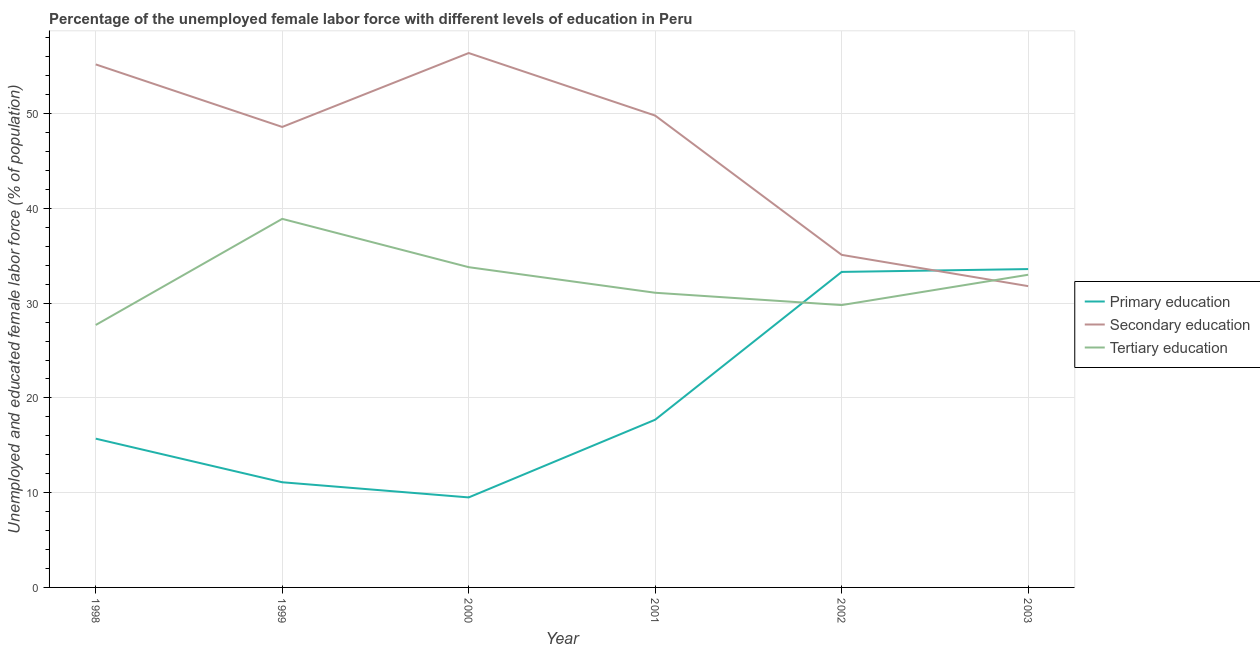Is the number of lines equal to the number of legend labels?
Make the answer very short. Yes. What is the percentage of female labor force who received primary education in 1999?
Offer a very short reply. 11.1. Across all years, what is the maximum percentage of female labor force who received primary education?
Offer a terse response. 33.6. Across all years, what is the minimum percentage of female labor force who received primary education?
Offer a very short reply. 9.5. What is the total percentage of female labor force who received tertiary education in the graph?
Your response must be concise. 194.3. What is the difference between the percentage of female labor force who received tertiary education in 1998 and that in 2000?
Your answer should be compact. -6.1. What is the difference between the percentage of female labor force who received tertiary education in 2001 and the percentage of female labor force who received secondary education in 2000?
Keep it short and to the point. -25.3. What is the average percentage of female labor force who received primary education per year?
Provide a succinct answer. 20.15. In the year 2003, what is the difference between the percentage of female labor force who received primary education and percentage of female labor force who received tertiary education?
Ensure brevity in your answer.  0.6. What is the ratio of the percentage of female labor force who received tertiary education in 1998 to that in 2001?
Offer a very short reply. 0.89. Is the percentage of female labor force who received primary education in 1998 less than that in 2001?
Provide a succinct answer. Yes. What is the difference between the highest and the second highest percentage of female labor force who received secondary education?
Provide a short and direct response. 1.2. What is the difference between the highest and the lowest percentage of female labor force who received primary education?
Keep it short and to the point. 24.1. In how many years, is the percentage of female labor force who received tertiary education greater than the average percentage of female labor force who received tertiary education taken over all years?
Your response must be concise. 3. Is the sum of the percentage of female labor force who received tertiary education in 1998 and 1999 greater than the maximum percentage of female labor force who received primary education across all years?
Ensure brevity in your answer.  Yes. Is it the case that in every year, the sum of the percentage of female labor force who received primary education and percentage of female labor force who received secondary education is greater than the percentage of female labor force who received tertiary education?
Give a very brief answer. Yes. Does the percentage of female labor force who received secondary education monotonically increase over the years?
Keep it short and to the point. No. Is the percentage of female labor force who received secondary education strictly less than the percentage of female labor force who received primary education over the years?
Offer a very short reply. No. How many lines are there?
Your response must be concise. 3. How many years are there in the graph?
Make the answer very short. 6. What is the difference between two consecutive major ticks on the Y-axis?
Keep it short and to the point. 10. Does the graph contain any zero values?
Give a very brief answer. No. Does the graph contain grids?
Give a very brief answer. Yes. How many legend labels are there?
Your answer should be compact. 3. How are the legend labels stacked?
Offer a terse response. Vertical. What is the title of the graph?
Provide a short and direct response. Percentage of the unemployed female labor force with different levels of education in Peru. What is the label or title of the X-axis?
Keep it short and to the point. Year. What is the label or title of the Y-axis?
Keep it short and to the point. Unemployed and educated female labor force (% of population). What is the Unemployed and educated female labor force (% of population) in Primary education in 1998?
Offer a very short reply. 15.7. What is the Unemployed and educated female labor force (% of population) of Secondary education in 1998?
Offer a terse response. 55.2. What is the Unemployed and educated female labor force (% of population) in Tertiary education in 1998?
Offer a very short reply. 27.7. What is the Unemployed and educated female labor force (% of population) of Primary education in 1999?
Offer a terse response. 11.1. What is the Unemployed and educated female labor force (% of population) in Secondary education in 1999?
Your answer should be very brief. 48.6. What is the Unemployed and educated female labor force (% of population) in Tertiary education in 1999?
Offer a very short reply. 38.9. What is the Unemployed and educated female labor force (% of population) of Secondary education in 2000?
Your answer should be very brief. 56.4. What is the Unemployed and educated female labor force (% of population) in Tertiary education in 2000?
Provide a succinct answer. 33.8. What is the Unemployed and educated female labor force (% of population) in Primary education in 2001?
Ensure brevity in your answer.  17.7. What is the Unemployed and educated female labor force (% of population) in Secondary education in 2001?
Your answer should be very brief. 49.8. What is the Unemployed and educated female labor force (% of population) of Tertiary education in 2001?
Your answer should be compact. 31.1. What is the Unemployed and educated female labor force (% of population) in Primary education in 2002?
Your answer should be very brief. 33.3. What is the Unemployed and educated female labor force (% of population) in Secondary education in 2002?
Your answer should be very brief. 35.1. What is the Unemployed and educated female labor force (% of population) in Tertiary education in 2002?
Provide a short and direct response. 29.8. What is the Unemployed and educated female labor force (% of population) in Primary education in 2003?
Ensure brevity in your answer.  33.6. What is the Unemployed and educated female labor force (% of population) of Secondary education in 2003?
Your response must be concise. 31.8. Across all years, what is the maximum Unemployed and educated female labor force (% of population) of Primary education?
Give a very brief answer. 33.6. Across all years, what is the maximum Unemployed and educated female labor force (% of population) of Secondary education?
Your answer should be very brief. 56.4. Across all years, what is the maximum Unemployed and educated female labor force (% of population) in Tertiary education?
Your response must be concise. 38.9. Across all years, what is the minimum Unemployed and educated female labor force (% of population) of Primary education?
Ensure brevity in your answer.  9.5. Across all years, what is the minimum Unemployed and educated female labor force (% of population) of Secondary education?
Give a very brief answer. 31.8. Across all years, what is the minimum Unemployed and educated female labor force (% of population) in Tertiary education?
Keep it short and to the point. 27.7. What is the total Unemployed and educated female labor force (% of population) in Primary education in the graph?
Give a very brief answer. 120.9. What is the total Unemployed and educated female labor force (% of population) in Secondary education in the graph?
Provide a succinct answer. 276.9. What is the total Unemployed and educated female labor force (% of population) in Tertiary education in the graph?
Your answer should be compact. 194.3. What is the difference between the Unemployed and educated female labor force (% of population) in Primary education in 1998 and that in 1999?
Give a very brief answer. 4.6. What is the difference between the Unemployed and educated female labor force (% of population) in Tertiary education in 1998 and that in 1999?
Ensure brevity in your answer.  -11.2. What is the difference between the Unemployed and educated female labor force (% of population) of Secondary education in 1998 and that in 2001?
Your response must be concise. 5.4. What is the difference between the Unemployed and educated female labor force (% of population) of Tertiary education in 1998 and that in 2001?
Your answer should be very brief. -3.4. What is the difference between the Unemployed and educated female labor force (% of population) in Primary education in 1998 and that in 2002?
Ensure brevity in your answer.  -17.6. What is the difference between the Unemployed and educated female labor force (% of population) of Secondary education in 1998 and that in 2002?
Provide a short and direct response. 20.1. What is the difference between the Unemployed and educated female labor force (% of population) of Tertiary education in 1998 and that in 2002?
Your answer should be very brief. -2.1. What is the difference between the Unemployed and educated female labor force (% of population) of Primary education in 1998 and that in 2003?
Your answer should be very brief. -17.9. What is the difference between the Unemployed and educated female labor force (% of population) of Secondary education in 1998 and that in 2003?
Your answer should be compact. 23.4. What is the difference between the Unemployed and educated female labor force (% of population) of Secondary education in 1999 and that in 2000?
Ensure brevity in your answer.  -7.8. What is the difference between the Unemployed and educated female labor force (% of population) of Primary education in 1999 and that in 2001?
Ensure brevity in your answer.  -6.6. What is the difference between the Unemployed and educated female labor force (% of population) in Secondary education in 1999 and that in 2001?
Your response must be concise. -1.2. What is the difference between the Unemployed and educated female labor force (% of population) in Tertiary education in 1999 and that in 2001?
Your answer should be very brief. 7.8. What is the difference between the Unemployed and educated female labor force (% of population) of Primary education in 1999 and that in 2002?
Offer a very short reply. -22.2. What is the difference between the Unemployed and educated female labor force (% of population) in Secondary education in 1999 and that in 2002?
Offer a terse response. 13.5. What is the difference between the Unemployed and educated female labor force (% of population) of Primary education in 1999 and that in 2003?
Offer a very short reply. -22.5. What is the difference between the Unemployed and educated female labor force (% of population) of Primary education in 2000 and that in 2001?
Make the answer very short. -8.2. What is the difference between the Unemployed and educated female labor force (% of population) of Secondary education in 2000 and that in 2001?
Offer a terse response. 6.6. What is the difference between the Unemployed and educated female labor force (% of population) in Tertiary education in 2000 and that in 2001?
Give a very brief answer. 2.7. What is the difference between the Unemployed and educated female labor force (% of population) of Primary education in 2000 and that in 2002?
Your answer should be compact. -23.8. What is the difference between the Unemployed and educated female labor force (% of population) of Secondary education in 2000 and that in 2002?
Offer a very short reply. 21.3. What is the difference between the Unemployed and educated female labor force (% of population) of Tertiary education in 2000 and that in 2002?
Provide a short and direct response. 4. What is the difference between the Unemployed and educated female labor force (% of population) in Primary education in 2000 and that in 2003?
Provide a short and direct response. -24.1. What is the difference between the Unemployed and educated female labor force (% of population) in Secondary education in 2000 and that in 2003?
Your answer should be very brief. 24.6. What is the difference between the Unemployed and educated female labor force (% of population) of Tertiary education in 2000 and that in 2003?
Provide a short and direct response. 0.8. What is the difference between the Unemployed and educated female labor force (% of population) of Primary education in 2001 and that in 2002?
Make the answer very short. -15.6. What is the difference between the Unemployed and educated female labor force (% of population) of Tertiary education in 2001 and that in 2002?
Provide a short and direct response. 1.3. What is the difference between the Unemployed and educated female labor force (% of population) in Primary education in 2001 and that in 2003?
Your response must be concise. -15.9. What is the difference between the Unemployed and educated female labor force (% of population) of Tertiary education in 2001 and that in 2003?
Your response must be concise. -1.9. What is the difference between the Unemployed and educated female labor force (% of population) in Secondary education in 2002 and that in 2003?
Your answer should be compact. 3.3. What is the difference between the Unemployed and educated female labor force (% of population) in Primary education in 1998 and the Unemployed and educated female labor force (% of population) in Secondary education in 1999?
Make the answer very short. -32.9. What is the difference between the Unemployed and educated female labor force (% of population) of Primary education in 1998 and the Unemployed and educated female labor force (% of population) of Tertiary education in 1999?
Offer a very short reply. -23.2. What is the difference between the Unemployed and educated female labor force (% of population) in Secondary education in 1998 and the Unemployed and educated female labor force (% of population) in Tertiary education in 1999?
Give a very brief answer. 16.3. What is the difference between the Unemployed and educated female labor force (% of population) in Primary education in 1998 and the Unemployed and educated female labor force (% of population) in Secondary education in 2000?
Make the answer very short. -40.7. What is the difference between the Unemployed and educated female labor force (% of population) of Primary education in 1998 and the Unemployed and educated female labor force (% of population) of Tertiary education in 2000?
Provide a short and direct response. -18.1. What is the difference between the Unemployed and educated female labor force (% of population) in Secondary education in 1998 and the Unemployed and educated female labor force (% of population) in Tertiary education in 2000?
Give a very brief answer. 21.4. What is the difference between the Unemployed and educated female labor force (% of population) of Primary education in 1998 and the Unemployed and educated female labor force (% of population) of Secondary education in 2001?
Offer a terse response. -34.1. What is the difference between the Unemployed and educated female labor force (% of population) in Primary education in 1998 and the Unemployed and educated female labor force (% of population) in Tertiary education in 2001?
Your answer should be very brief. -15.4. What is the difference between the Unemployed and educated female labor force (% of population) in Secondary education in 1998 and the Unemployed and educated female labor force (% of population) in Tertiary education in 2001?
Offer a terse response. 24.1. What is the difference between the Unemployed and educated female labor force (% of population) of Primary education in 1998 and the Unemployed and educated female labor force (% of population) of Secondary education in 2002?
Keep it short and to the point. -19.4. What is the difference between the Unemployed and educated female labor force (% of population) of Primary education in 1998 and the Unemployed and educated female labor force (% of population) of Tertiary education in 2002?
Provide a short and direct response. -14.1. What is the difference between the Unemployed and educated female labor force (% of population) in Secondary education in 1998 and the Unemployed and educated female labor force (% of population) in Tertiary education in 2002?
Your answer should be very brief. 25.4. What is the difference between the Unemployed and educated female labor force (% of population) of Primary education in 1998 and the Unemployed and educated female labor force (% of population) of Secondary education in 2003?
Provide a short and direct response. -16.1. What is the difference between the Unemployed and educated female labor force (% of population) in Primary education in 1998 and the Unemployed and educated female labor force (% of population) in Tertiary education in 2003?
Offer a very short reply. -17.3. What is the difference between the Unemployed and educated female labor force (% of population) in Primary education in 1999 and the Unemployed and educated female labor force (% of population) in Secondary education in 2000?
Offer a terse response. -45.3. What is the difference between the Unemployed and educated female labor force (% of population) of Primary education in 1999 and the Unemployed and educated female labor force (% of population) of Tertiary education in 2000?
Make the answer very short. -22.7. What is the difference between the Unemployed and educated female labor force (% of population) in Secondary education in 1999 and the Unemployed and educated female labor force (% of population) in Tertiary education in 2000?
Ensure brevity in your answer.  14.8. What is the difference between the Unemployed and educated female labor force (% of population) in Primary education in 1999 and the Unemployed and educated female labor force (% of population) in Secondary education in 2001?
Offer a very short reply. -38.7. What is the difference between the Unemployed and educated female labor force (% of population) in Primary education in 1999 and the Unemployed and educated female labor force (% of population) in Tertiary education in 2001?
Offer a very short reply. -20. What is the difference between the Unemployed and educated female labor force (% of population) of Secondary education in 1999 and the Unemployed and educated female labor force (% of population) of Tertiary education in 2001?
Offer a terse response. 17.5. What is the difference between the Unemployed and educated female labor force (% of population) in Primary education in 1999 and the Unemployed and educated female labor force (% of population) in Secondary education in 2002?
Offer a terse response. -24. What is the difference between the Unemployed and educated female labor force (% of population) in Primary education in 1999 and the Unemployed and educated female labor force (% of population) in Tertiary education in 2002?
Make the answer very short. -18.7. What is the difference between the Unemployed and educated female labor force (% of population) in Secondary education in 1999 and the Unemployed and educated female labor force (% of population) in Tertiary education in 2002?
Ensure brevity in your answer.  18.8. What is the difference between the Unemployed and educated female labor force (% of population) of Primary education in 1999 and the Unemployed and educated female labor force (% of population) of Secondary education in 2003?
Offer a terse response. -20.7. What is the difference between the Unemployed and educated female labor force (% of population) in Primary education in 1999 and the Unemployed and educated female labor force (% of population) in Tertiary education in 2003?
Ensure brevity in your answer.  -21.9. What is the difference between the Unemployed and educated female labor force (% of population) in Primary education in 2000 and the Unemployed and educated female labor force (% of population) in Secondary education in 2001?
Your answer should be very brief. -40.3. What is the difference between the Unemployed and educated female labor force (% of population) of Primary education in 2000 and the Unemployed and educated female labor force (% of population) of Tertiary education in 2001?
Give a very brief answer. -21.6. What is the difference between the Unemployed and educated female labor force (% of population) in Secondary education in 2000 and the Unemployed and educated female labor force (% of population) in Tertiary education in 2001?
Your answer should be very brief. 25.3. What is the difference between the Unemployed and educated female labor force (% of population) in Primary education in 2000 and the Unemployed and educated female labor force (% of population) in Secondary education in 2002?
Offer a terse response. -25.6. What is the difference between the Unemployed and educated female labor force (% of population) of Primary education in 2000 and the Unemployed and educated female labor force (% of population) of Tertiary education in 2002?
Your response must be concise. -20.3. What is the difference between the Unemployed and educated female labor force (% of population) in Secondary education in 2000 and the Unemployed and educated female labor force (% of population) in Tertiary education in 2002?
Offer a terse response. 26.6. What is the difference between the Unemployed and educated female labor force (% of population) in Primary education in 2000 and the Unemployed and educated female labor force (% of population) in Secondary education in 2003?
Your answer should be very brief. -22.3. What is the difference between the Unemployed and educated female labor force (% of population) in Primary education in 2000 and the Unemployed and educated female labor force (% of population) in Tertiary education in 2003?
Keep it short and to the point. -23.5. What is the difference between the Unemployed and educated female labor force (% of population) of Secondary education in 2000 and the Unemployed and educated female labor force (% of population) of Tertiary education in 2003?
Provide a short and direct response. 23.4. What is the difference between the Unemployed and educated female labor force (% of population) of Primary education in 2001 and the Unemployed and educated female labor force (% of population) of Secondary education in 2002?
Provide a succinct answer. -17.4. What is the difference between the Unemployed and educated female labor force (% of population) of Primary education in 2001 and the Unemployed and educated female labor force (% of population) of Tertiary education in 2002?
Make the answer very short. -12.1. What is the difference between the Unemployed and educated female labor force (% of population) in Primary education in 2001 and the Unemployed and educated female labor force (% of population) in Secondary education in 2003?
Your response must be concise. -14.1. What is the difference between the Unemployed and educated female labor force (% of population) of Primary education in 2001 and the Unemployed and educated female labor force (% of population) of Tertiary education in 2003?
Give a very brief answer. -15.3. What is the difference between the Unemployed and educated female labor force (% of population) in Secondary education in 2001 and the Unemployed and educated female labor force (% of population) in Tertiary education in 2003?
Your answer should be very brief. 16.8. What is the difference between the Unemployed and educated female labor force (% of population) of Primary education in 2002 and the Unemployed and educated female labor force (% of population) of Secondary education in 2003?
Make the answer very short. 1.5. What is the average Unemployed and educated female labor force (% of population) in Primary education per year?
Provide a short and direct response. 20.15. What is the average Unemployed and educated female labor force (% of population) of Secondary education per year?
Your answer should be compact. 46.15. What is the average Unemployed and educated female labor force (% of population) of Tertiary education per year?
Give a very brief answer. 32.38. In the year 1998, what is the difference between the Unemployed and educated female labor force (% of population) in Primary education and Unemployed and educated female labor force (% of population) in Secondary education?
Your response must be concise. -39.5. In the year 1998, what is the difference between the Unemployed and educated female labor force (% of population) in Primary education and Unemployed and educated female labor force (% of population) in Tertiary education?
Offer a very short reply. -12. In the year 1999, what is the difference between the Unemployed and educated female labor force (% of population) of Primary education and Unemployed and educated female labor force (% of population) of Secondary education?
Offer a very short reply. -37.5. In the year 1999, what is the difference between the Unemployed and educated female labor force (% of population) of Primary education and Unemployed and educated female labor force (% of population) of Tertiary education?
Give a very brief answer. -27.8. In the year 1999, what is the difference between the Unemployed and educated female labor force (% of population) of Secondary education and Unemployed and educated female labor force (% of population) of Tertiary education?
Your answer should be very brief. 9.7. In the year 2000, what is the difference between the Unemployed and educated female labor force (% of population) of Primary education and Unemployed and educated female labor force (% of population) of Secondary education?
Provide a short and direct response. -46.9. In the year 2000, what is the difference between the Unemployed and educated female labor force (% of population) in Primary education and Unemployed and educated female labor force (% of population) in Tertiary education?
Ensure brevity in your answer.  -24.3. In the year 2000, what is the difference between the Unemployed and educated female labor force (% of population) in Secondary education and Unemployed and educated female labor force (% of population) in Tertiary education?
Your response must be concise. 22.6. In the year 2001, what is the difference between the Unemployed and educated female labor force (% of population) in Primary education and Unemployed and educated female labor force (% of population) in Secondary education?
Your answer should be compact. -32.1. In the year 2001, what is the difference between the Unemployed and educated female labor force (% of population) in Primary education and Unemployed and educated female labor force (% of population) in Tertiary education?
Your answer should be very brief. -13.4. In the year 2001, what is the difference between the Unemployed and educated female labor force (% of population) in Secondary education and Unemployed and educated female labor force (% of population) in Tertiary education?
Make the answer very short. 18.7. In the year 2002, what is the difference between the Unemployed and educated female labor force (% of population) in Primary education and Unemployed and educated female labor force (% of population) in Tertiary education?
Offer a terse response. 3.5. In the year 2003, what is the difference between the Unemployed and educated female labor force (% of population) in Primary education and Unemployed and educated female labor force (% of population) in Secondary education?
Provide a succinct answer. 1.8. What is the ratio of the Unemployed and educated female labor force (% of population) in Primary education in 1998 to that in 1999?
Offer a very short reply. 1.41. What is the ratio of the Unemployed and educated female labor force (% of population) in Secondary education in 1998 to that in 1999?
Ensure brevity in your answer.  1.14. What is the ratio of the Unemployed and educated female labor force (% of population) of Tertiary education in 1998 to that in 1999?
Offer a very short reply. 0.71. What is the ratio of the Unemployed and educated female labor force (% of population) in Primary education in 1998 to that in 2000?
Provide a succinct answer. 1.65. What is the ratio of the Unemployed and educated female labor force (% of population) in Secondary education in 1998 to that in 2000?
Your answer should be compact. 0.98. What is the ratio of the Unemployed and educated female labor force (% of population) in Tertiary education in 1998 to that in 2000?
Ensure brevity in your answer.  0.82. What is the ratio of the Unemployed and educated female labor force (% of population) in Primary education in 1998 to that in 2001?
Keep it short and to the point. 0.89. What is the ratio of the Unemployed and educated female labor force (% of population) in Secondary education in 1998 to that in 2001?
Ensure brevity in your answer.  1.11. What is the ratio of the Unemployed and educated female labor force (% of population) in Tertiary education in 1998 to that in 2001?
Make the answer very short. 0.89. What is the ratio of the Unemployed and educated female labor force (% of population) of Primary education in 1998 to that in 2002?
Offer a terse response. 0.47. What is the ratio of the Unemployed and educated female labor force (% of population) in Secondary education in 1998 to that in 2002?
Provide a succinct answer. 1.57. What is the ratio of the Unemployed and educated female labor force (% of population) in Tertiary education in 1998 to that in 2002?
Make the answer very short. 0.93. What is the ratio of the Unemployed and educated female labor force (% of population) in Primary education in 1998 to that in 2003?
Ensure brevity in your answer.  0.47. What is the ratio of the Unemployed and educated female labor force (% of population) of Secondary education in 1998 to that in 2003?
Offer a very short reply. 1.74. What is the ratio of the Unemployed and educated female labor force (% of population) of Tertiary education in 1998 to that in 2003?
Make the answer very short. 0.84. What is the ratio of the Unemployed and educated female labor force (% of population) of Primary education in 1999 to that in 2000?
Your response must be concise. 1.17. What is the ratio of the Unemployed and educated female labor force (% of population) in Secondary education in 1999 to that in 2000?
Provide a succinct answer. 0.86. What is the ratio of the Unemployed and educated female labor force (% of population) in Tertiary education in 1999 to that in 2000?
Ensure brevity in your answer.  1.15. What is the ratio of the Unemployed and educated female labor force (% of population) of Primary education in 1999 to that in 2001?
Make the answer very short. 0.63. What is the ratio of the Unemployed and educated female labor force (% of population) in Secondary education in 1999 to that in 2001?
Your answer should be compact. 0.98. What is the ratio of the Unemployed and educated female labor force (% of population) of Tertiary education in 1999 to that in 2001?
Your response must be concise. 1.25. What is the ratio of the Unemployed and educated female labor force (% of population) in Secondary education in 1999 to that in 2002?
Keep it short and to the point. 1.38. What is the ratio of the Unemployed and educated female labor force (% of population) in Tertiary education in 1999 to that in 2002?
Offer a very short reply. 1.31. What is the ratio of the Unemployed and educated female labor force (% of population) of Primary education in 1999 to that in 2003?
Keep it short and to the point. 0.33. What is the ratio of the Unemployed and educated female labor force (% of population) in Secondary education in 1999 to that in 2003?
Your answer should be compact. 1.53. What is the ratio of the Unemployed and educated female labor force (% of population) of Tertiary education in 1999 to that in 2003?
Your answer should be compact. 1.18. What is the ratio of the Unemployed and educated female labor force (% of population) of Primary education in 2000 to that in 2001?
Offer a very short reply. 0.54. What is the ratio of the Unemployed and educated female labor force (% of population) of Secondary education in 2000 to that in 2001?
Ensure brevity in your answer.  1.13. What is the ratio of the Unemployed and educated female labor force (% of population) in Tertiary education in 2000 to that in 2001?
Keep it short and to the point. 1.09. What is the ratio of the Unemployed and educated female labor force (% of population) of Primary education in 2000 to that in 2002?
Your response must be concise. 0.29. What is the ratio of the Unemployed and educated female labor force (% of population) of Secondary education in 2000 to that in 2002?
Give a very brief answer. 1.61. What is the ratio of the Unemployed and educated female labor force (% of population) in Tertiary education in 2000 to that in 2002?
Your answer should be compact. 1.13. What is the ratio of the Unemployed and educated female labor force (% of population) in Primary education in 2000 to that in 2003?
Offer a terse response. 0.28. What is the ratio of the Unemployed and educated female labor force (% of population) of Secondary education in 2000 to that in 2003?
Your response must be concise. 1.77. What is the ratio of the Unemployed and educated female labor force (% of population) in Tertiary education in 2000 to that in 2003?
Provide a succinct answer. 1.02. What is the ratio of the Unemployed and educated female labor force (% of population) in Primary education in 2001 to that in 2002?
Give a very brief answer. 0.53. What is the ratio of the Unemployed and educated female labor force (% of population) of Secondary education in 2001 to that in 2002?
Provide a short and direct response. 1.42. What is the ratio of the Unemployed and educated female labor force (% of population) in Tertiary education in 2001 to that in 2002?
Provide a succinct answer. 1.04. What is the ratio of the Unemployed and educated female labor force (% of population) in Primary education in 2001 to that in 2003?
Your answer should be very brief. 0.53. What is the ratio of the Unemployed and educated female labor force (% of population) of Secondary education in 2001 to that in 2003?
Provide a short and direct response. 1.57. What is the ratio of the Unemployed and educated female labor force (% of population) of Tertiary education in 2001 to that in 2003?
Make the answer very short. 0.94. What is the ratio of the Unemployed and educated female labor force (% of population) of Secondary education in 2002 to that in 2003?
Make the answer very short. 1.1. What is the ratio of the Unemployed and educated female labor force (% of population) in Tertiary education in 2002 to that in 2003?
Give a very brief answer. 0.9. What is the difference between the highest and the second highest Unemployed and educated female labor force (% of population) of Primary education?
Your response must be concise. 0.3. What is the difference between the highest and the lowest Unemployed and educated female labor force (% of population) in Primary education?
Your answer should be very brief. 24.1. What is the difference between the highest and the lowest Unemployed and educated female labor force (% of population) of Secondary education?
Your response must be concise. 24.6. 